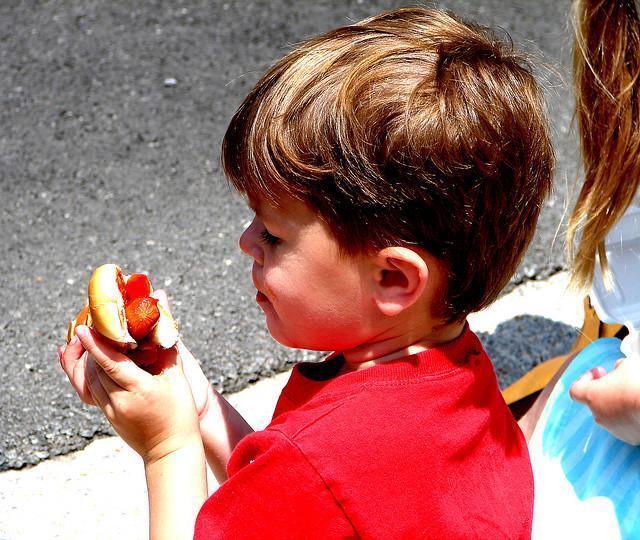How many people are in the picture?
Give a very brief answer. 2. 